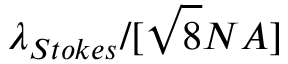Convert formula to latex. <formula><loc_0><loc_0><loc_500><loc_500>\lambda _ { S t o k e s } / [ \sqrt { 8 } N A ]</formula> 